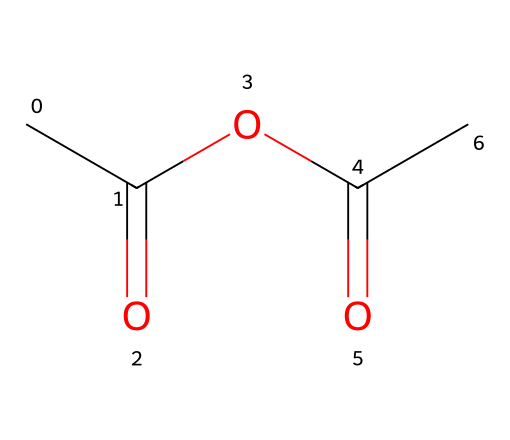What is the molecular formula of acetic anhydride? By analyzing the structure, we can identify the atoms present: there are 4 carbon (C) atoms, 6 hydrogen (H) atoms, and 2 oxygen (O) atoms. Thus, the molecular formula is derived as C4H6O2.
Answer: C4H6O2 How many carbon atoms are present in acetic anhydride? Upon inspection of the chemical structure, we identify a total of 4 carbon atoms connected within the molecule.
Answer: 4 What type of functional groups are present in acetic anhydride? The structure displays an anhydride functional group (seen with the carbonyl and ether linkage) alongside the acetate groups, indicating that it contains both acyl and ether functionalities.
Answer: anhydride, acetate How many double bonds are present in acetic anhydride? The chemical structure shows two carbonyl groups (C=O) which are characterized as double bonds. Therefore, there are 2 double bonds in the structure.
Answer: 2 What is the primary use of acetic anhydride in veterinary medicine? Acetic anhydride is often used as a reagent in the synthesis of various pharmaceutical compounds, which may include medications used in animal treatment and care.
Answer: synthesis of pharmaceuticals What type of reaction can acetic anhydride undergo? Acetic anhydride can undergo nucleophilic acyl substitution reactions due to the reactivity of the anhydride group, which can form new bonds with nucleophiles.
Answer: nucleophilic acyl substitution What is the expected general reactivity of acetic anhydride compared to acetic acid? Acetic anhydride is more reactive than acetic acid because the anhydride form contains two carbonyl groups that can facilitate more varied chemical reactions than acetic acid, which has only one.
Answer: more reactive 